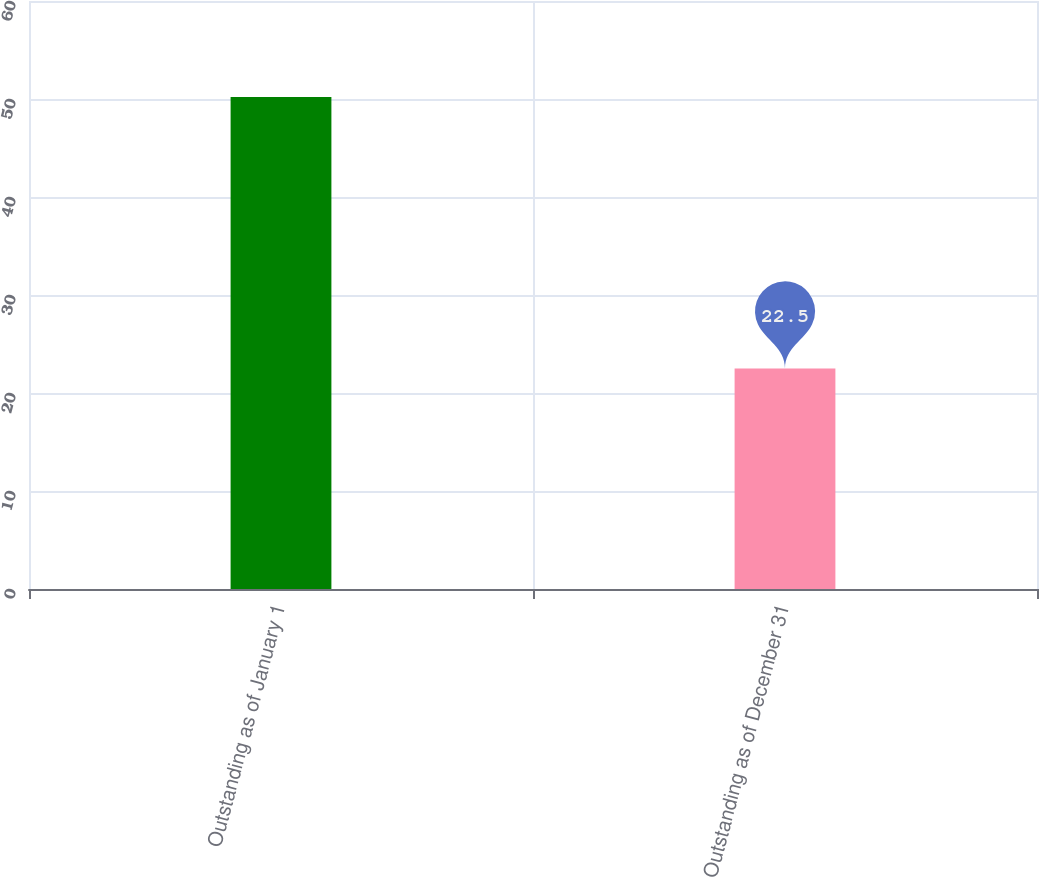<chart> <loc_0><loc_0><loc_500><loc_500><bar_chart><fcel>Outstanding as of January 1<fcel>Outstanding as of December 31<nl><fcel>50.21<fcel>22.5<nl></chart> 